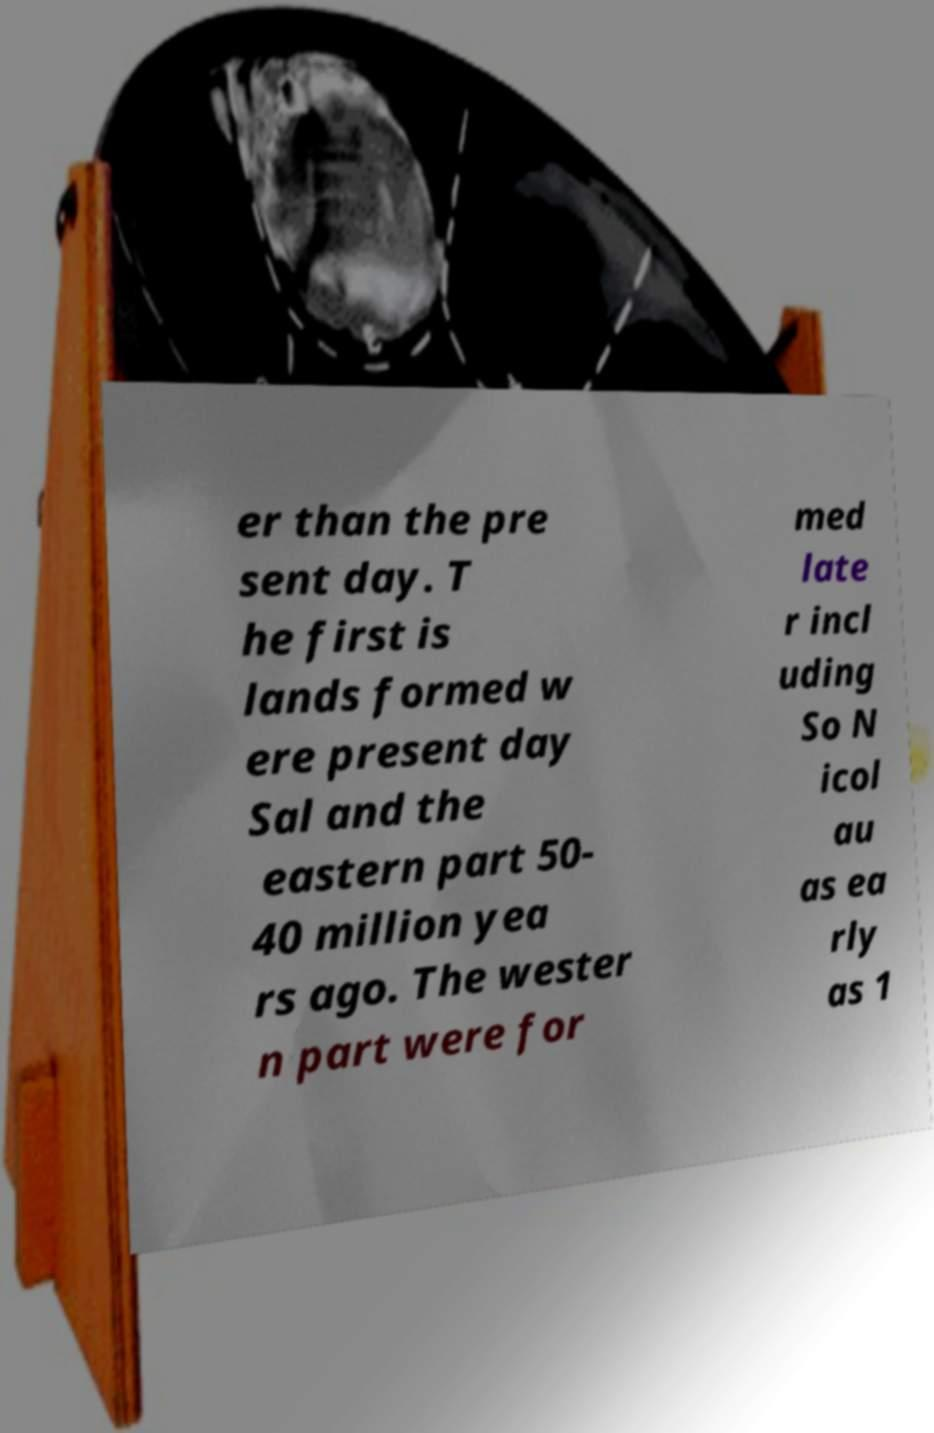Please identify and transcribe the text found in this image. er than the pre sent day. T he first is lands formed w ere present day Sal and the eastern part 50- 40 million yea rs ago. The wester n part were for med late r incl uding So N icol au as ea rly as 1 